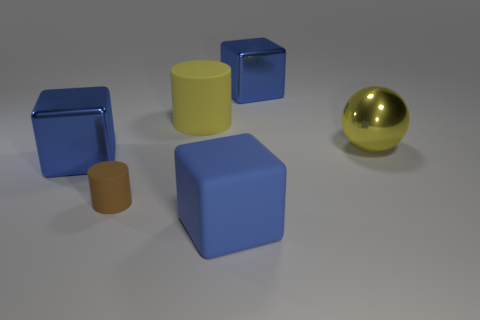Are there any other things that have the same size as the brown cylinder?
Provide a succinct answer. No. There is a big yellow object to the right of the cube that is in front of the tiny thing; what is its shape?
Your response must be concise. Sphere. Do the large metallic sphere and the tiny cylinder have the same color?
Your answer should be very brief. No. Are there more brown objects in front of the brown cylinder than big rubber objects?
Offer a very short reply. No. There is a blue block right of the large blue matte cube; how many large shiny balls are to the right of it?
Provide a succinct answer. 1. Is the material of the big cube that is in front of the small brown cylinder the same as the large block that is behind the big metallic sphere?
Ensure brevity in your answer.  No. What material is the sphere that is the same color as the large rubber cylinder?
Offer a terse response. Metal. How many brown things have the same shape as the yellow matte object?
Keep it short and to the point. 1. Are the large yellow cylinder and the block left of the tiny brown cylinder made of the same material?
Your response must be concise. No. There is a yellow ball that is the same size as the yellow cylinder; what material is it?
Give a very brief answer. Metal. 